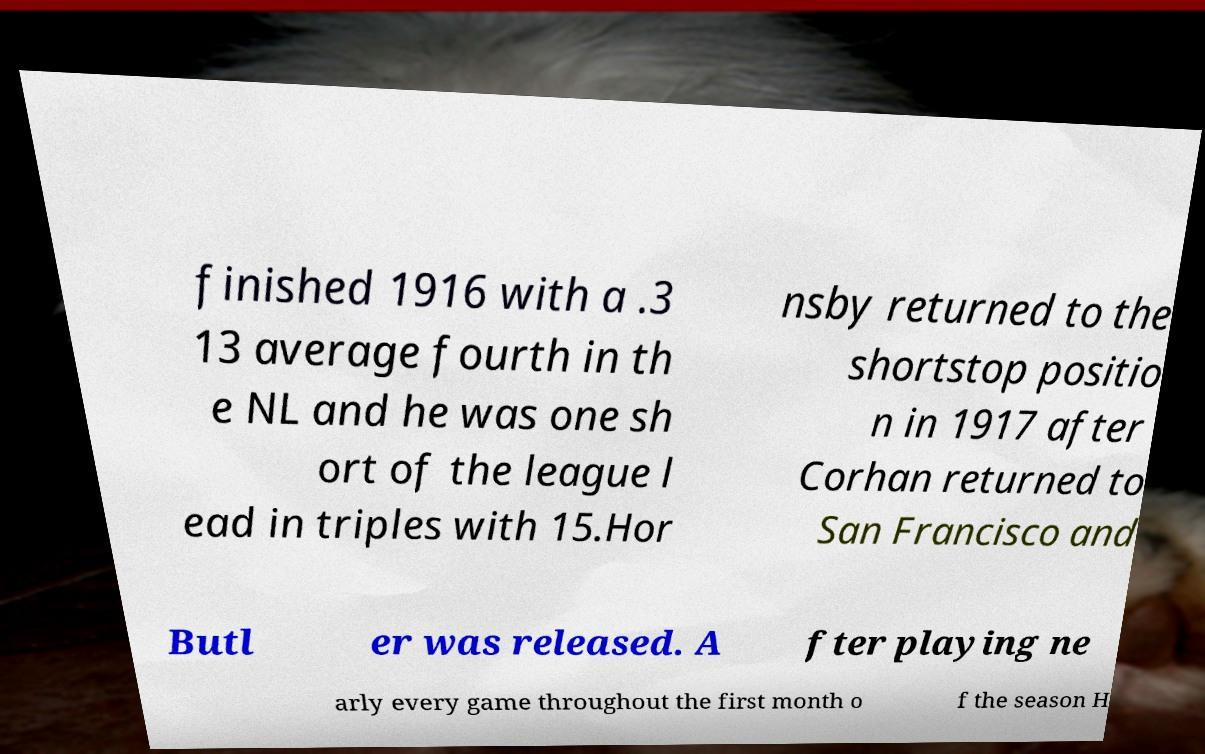Please identify and transcribe the text found in this image. finished 1916 with a .3 13 average fourth in th e NL and he was one sh ort of the league l ead in triples with 15.Hor nsby returned to the shortstop positio n in 1917 after Corhan returned to San Francisco and Butl er was released. A fter playing ne arly every game throughout the first month o f the season H 